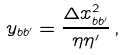Convert formula to latex. <formula><loc_0><loc_0><loc_500><loc_500>y _ { b b ^ { \prime } } = \frac { \Delta x _ { b b ^ { \prime } } ^ { 2 } } { \eta \eta ^ { \prime } } \, ,</formula> 